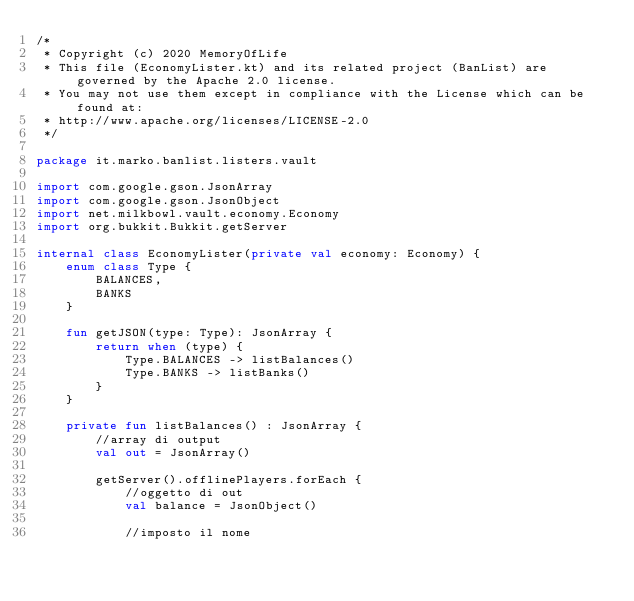<code> <loc_0><loc_0><loc_500><loc_500><_Kotlin_>/*
 * Copyright (c) 2020 MemoryOfLife
 * This file (EconomyLister.kt) and its related project (BanList) are governed by the Apache 2.0 license.
 * You may not use them except in compliance with the License which can be found at:
 * http://www.apache.org/licenses/LICENSE-2.0
 */

package it.marko.banlist.listers.vault

import com.google.gson.JsonArray
import com.google.gson.JsonObject
import net.milkbowl.vault.economy.Economy
import org.bukkit.Bukkit.getServer

internal class EconomyLister(private val economy: Economy) {
    enum class Type {
        BALANCES,
        BANKS
    }

    fun getJSON(type: Type): JsonArray {
        return when (type) {
            Type.BALANCES -> listBalances()
            Type.BANKS -> listBanks()
        }
    }

    private fun listBalances() : JsonArray {
        //array di output
        val out = JsonArray()

        getServer().offlinePlayers.forEach {
            //oggetto di out
            val balance = JsonObject()

            //imposto il nome</code> 